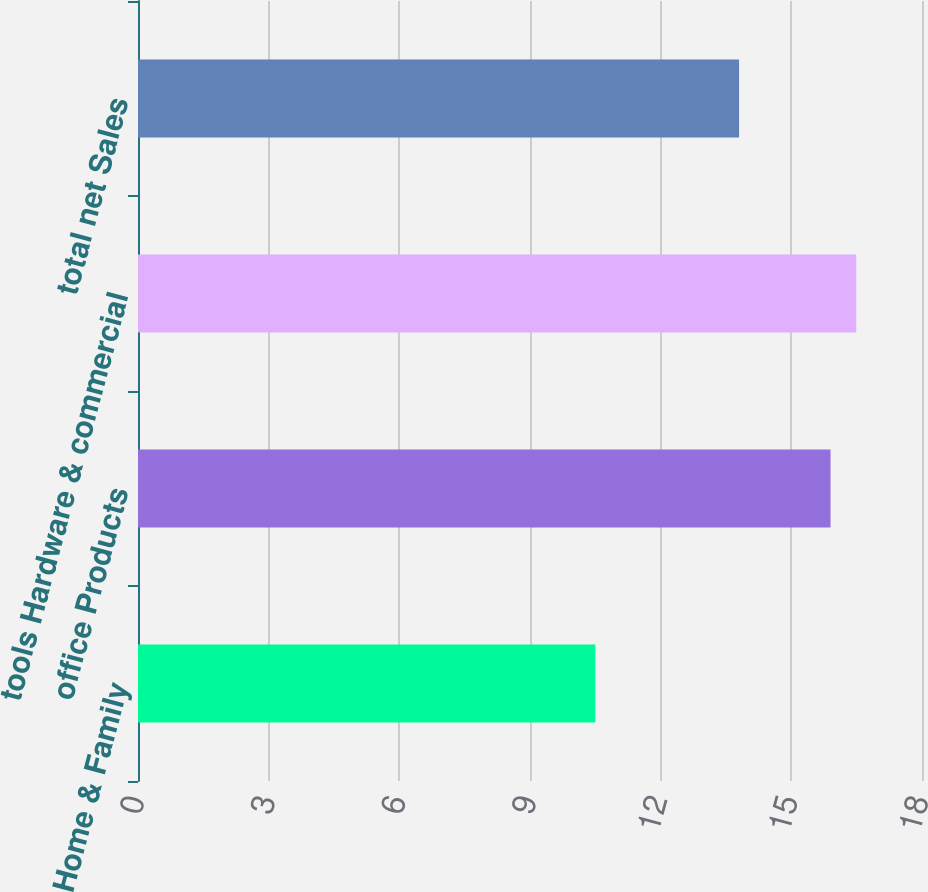<chart> <loc_0><loc_0><loc_500><loc_500><bar_chart><fcel>Home & Family<fcel>office Products<fcel>tools Hardware & commercial<fcel>total net Sales<nl><fcel>10.5<fcel>15.9<fcel>16.49<fcel>13.8<nl></chart> 